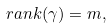Convert formula to latex. <formula><loc_0><loc_0><loc_500><loc_500>\ r a n k ( \gamma ) = m ,</formula> 